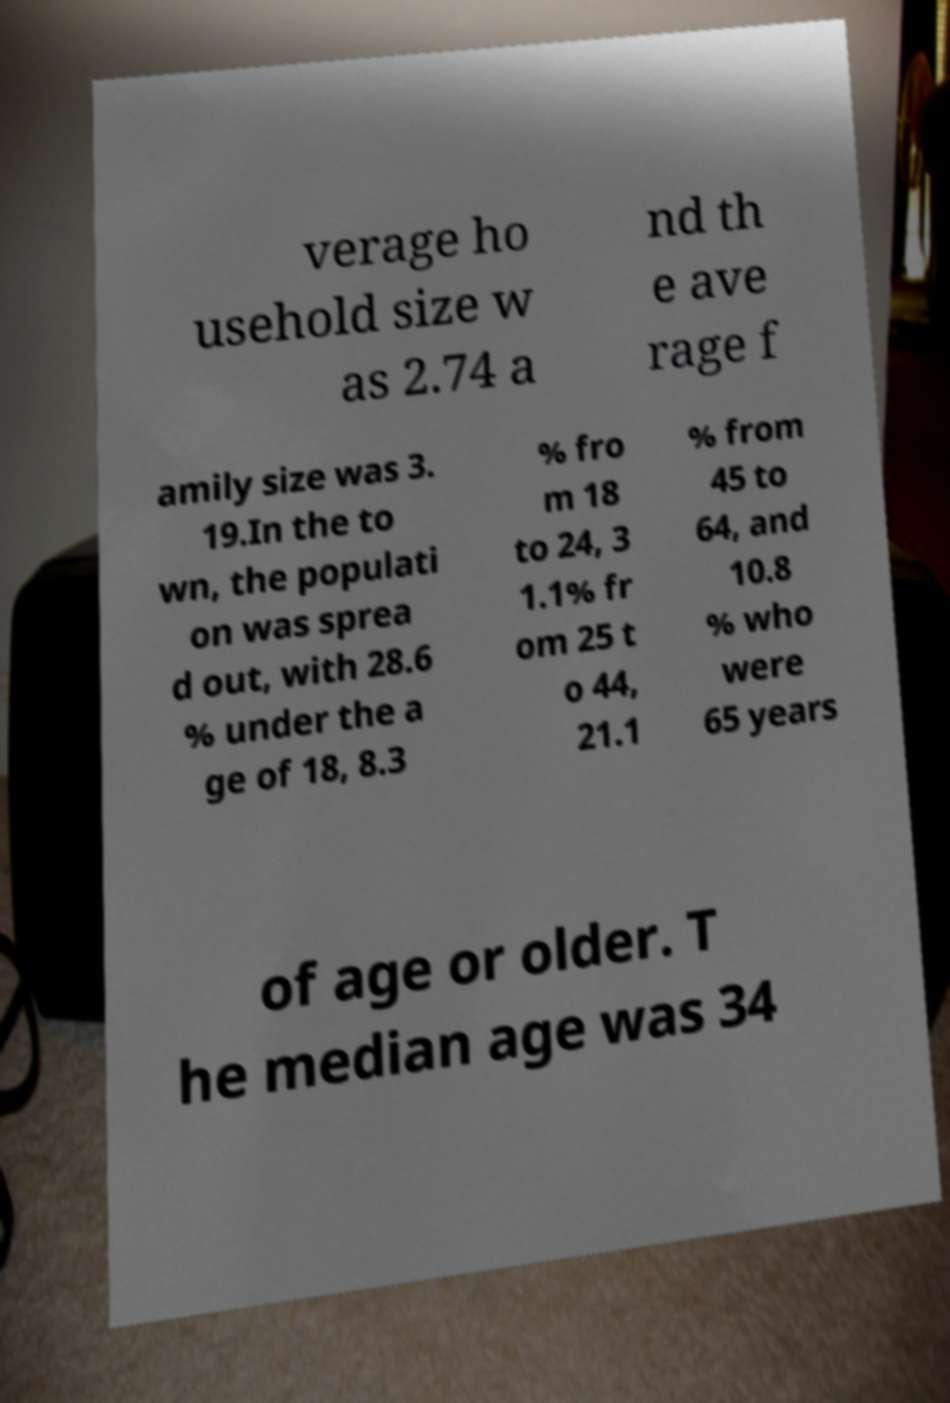For documentation purposes, I need the text within this image transcribed. Could you provide that? verage ho usehold size w as 2.74 a nd th e ave rage f amily size was 3. 19.In the to wn, the populati on was sprea d out, with 28.6 % under the a ge of 18, 8.3 % fro m 18 to 24, 3 1.1% fr om 25 t o 44, 21.1 % from 45 to 64, and 10.8 % who were 65 years of age or older. T he median age was 34 